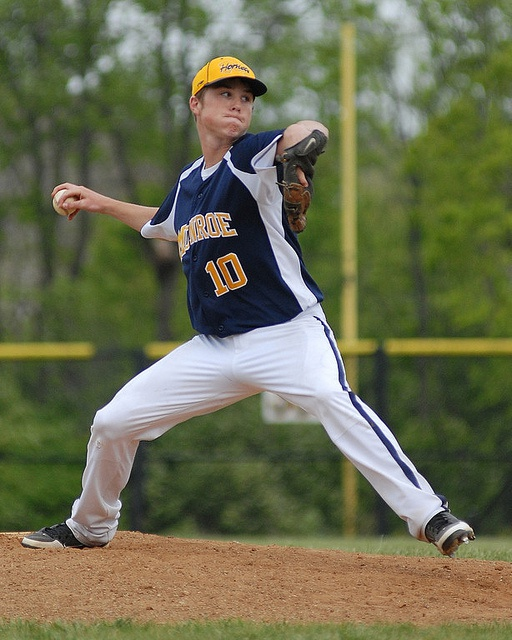Describe the objects in this image and their specific colors. I can see people in green, lavender, black, darkgray, and gray tones, baseball glove in green, black, gray, maroon, and darkgreen tones, and sports ball in green, tan, beige, gray, and maroon tones in this image. 